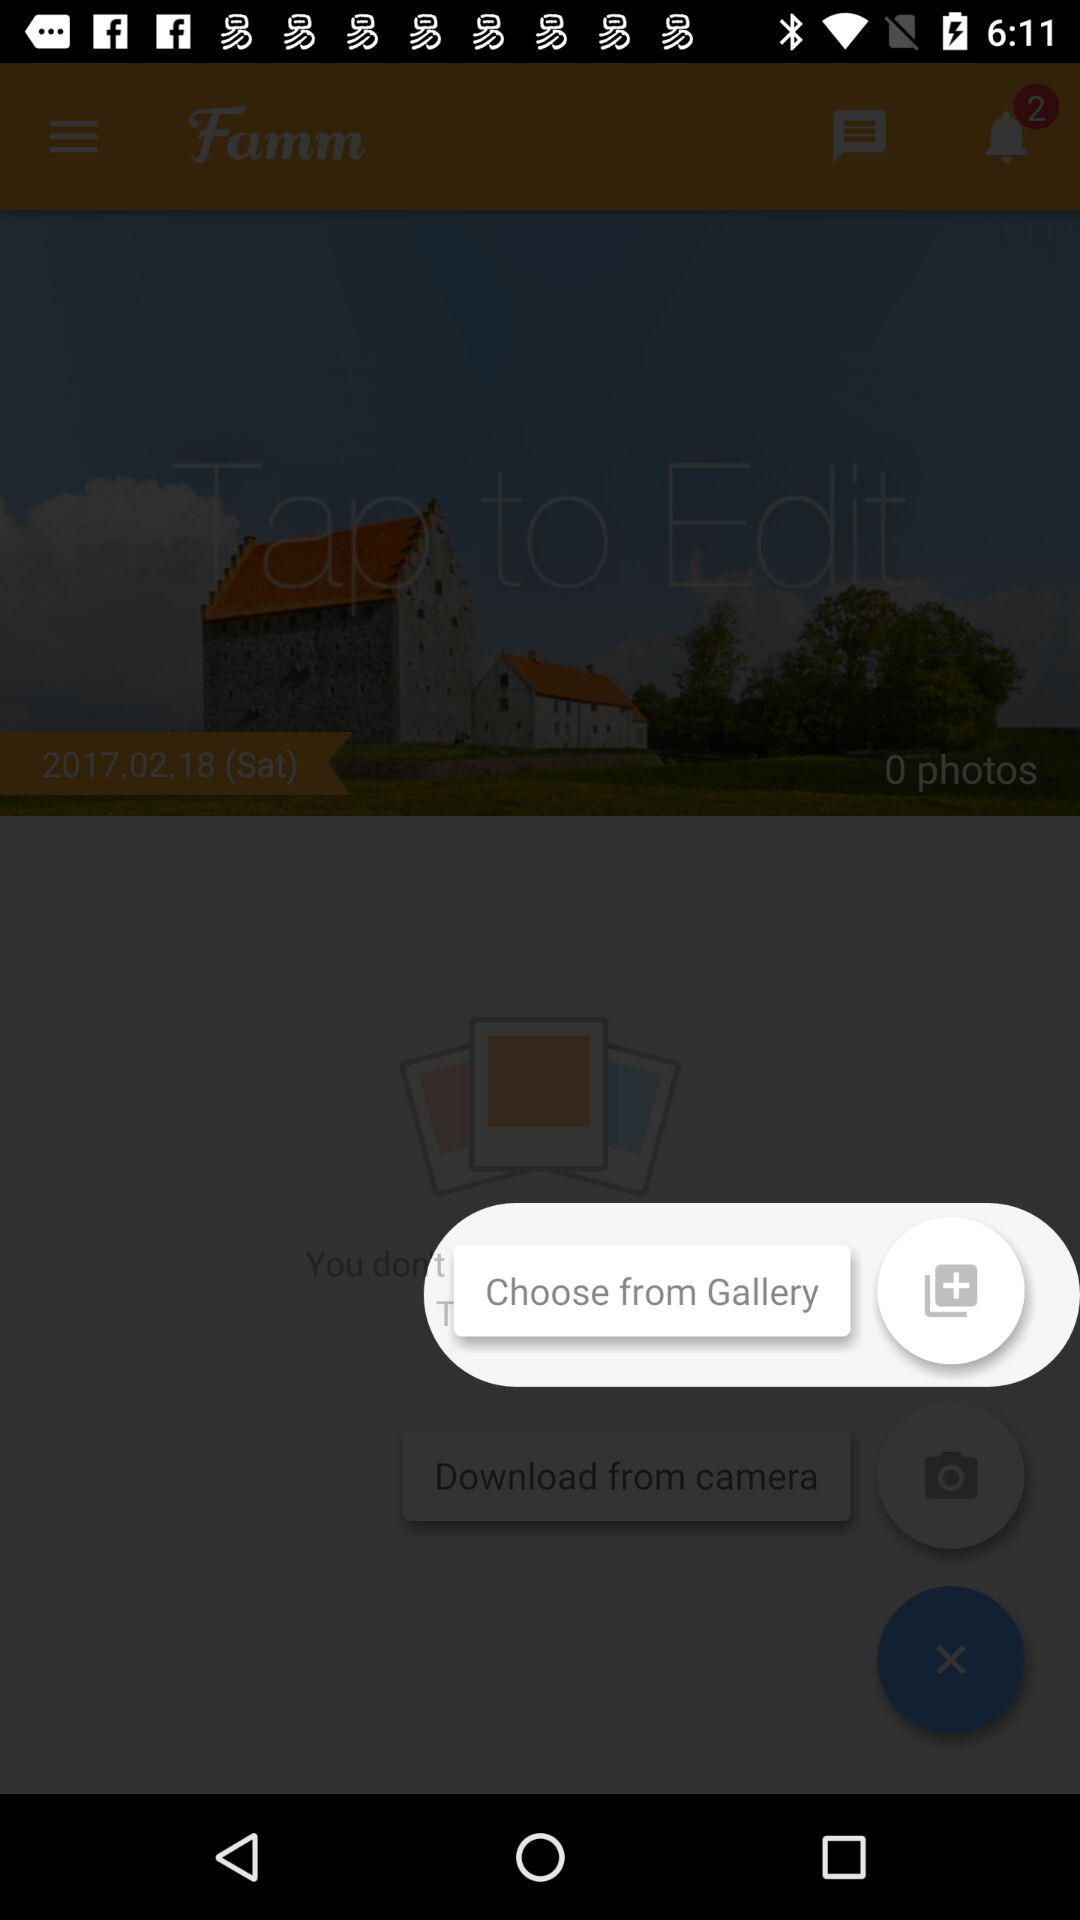Which option is given to choose from? The given option is "Gallery". 